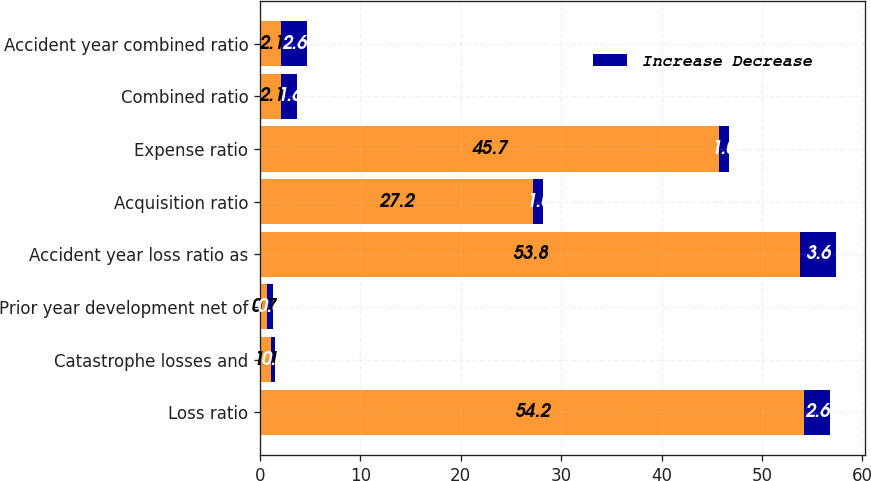Convert chart to OTSL. <chart><loc_0><loc_0><loc_500><loc_500><stacked_bar_chart><ecel><fcel>Loss ratio<fcel>Catastrophe losses and<fcel>Prior year development net of<fcel>Accident year loss ratio as<fcel>Acquisition ratio<fcel>Expense ratio<fcel>Combined ratio<fcel>Accident year combined ratio<nl><fcel>nan<fcel>54.2<fcel>1.1<fcel>0.7<fcel>53.8<fcel>27.2<fcel>45.7<fcel>2.1<fcel>2.1<nl><fcel>Increase Decrease<fcel>2.6<fcel>0.4<fcel>0.6<fcel>3.6<fcel>1<fcel>1<fcel>1.6<fcel>2.6<nl></chart> 